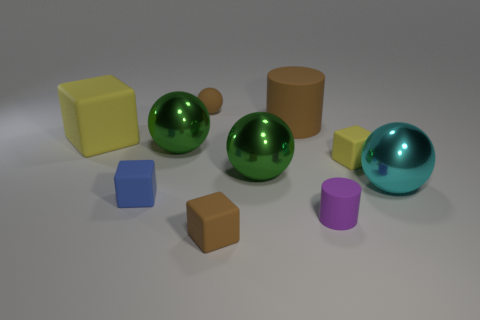What is the color of the small matte cube in front of the small cylinder that is in front of the tiny blue rubber object?
Offer a very short reply. Brown. Do the blue rubber thing and the cyan shiny thing have the same size?
Your answer should be compact. No. What is the color of the tiny rubber cube that is both behind the small purple cylinder and to the left of the large brown matte cylinder?
Offer a very short reply. Blue. The brown rubber cylinder is what size?
Offer a very short reply. Large. There is a cylinder in front of the cyan thing; is it the same color as the matte ball?
Make the answer very short. No. Are there more brown matte cylinders in front of the blue matte cube than brown things to the right of the purple rubber thing?
Provide a short and direct response. No. Is the number of tiny rubber cylinders greater than the number of tiny things?
Make the answer very short. No. How big is the object that is left of the purple thing and in front of the blue matte cube?
Offer a very short reply. Small. What shape is the blue object?
Make the answer very short. Cube. Is there any other thing that is the same size as the brown ball?
Keep it short and to the point. Yes. 